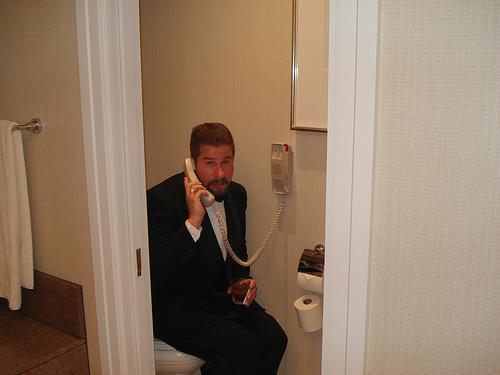How many people are there?
Give a very brief answer. 1. 